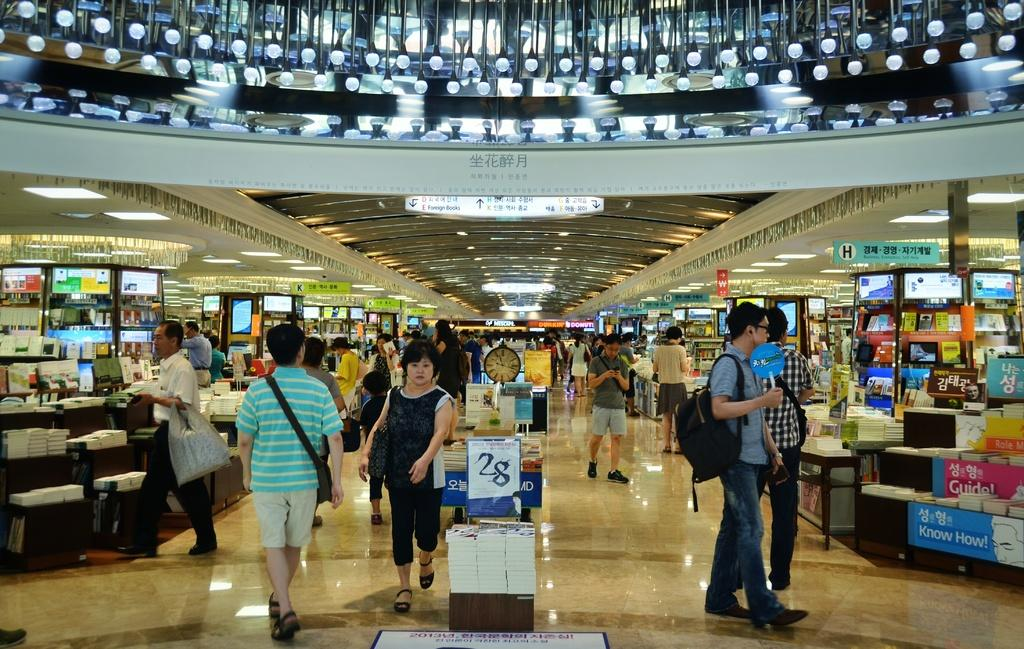<image>
Write a terse but informative summary of the picture. the number 28 is on the white paper near the people 